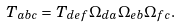Convert formula to latex. <formula><loc_0><loc_0><loc_500><loc_500>T _ { a b c } = T _ { d e f } \Omega _ { d a } \Omega _ { e b } \Omega _ { f c } .</formula> 